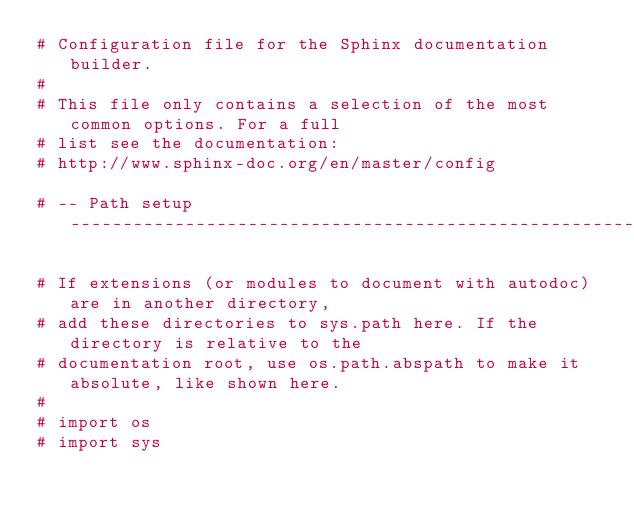<code> <loc_0><loc_0><loc_500><loc_500><_Python_># Configuration file for the Sphinx documentation builder.
#
# This file only contains a selection of the most common options. For a full
# list see the documentation:
# http://www.sphinx-doc.org/en/master/config

# -- Path setup --------------------------------------------------------------

# If extensions (or modules to document with autodoc) are in another directory,
# add these directories to sys.path here. If the directory is relative to the
# documentation root, use os.path.abspath to make it absolute, like shown here.
#
# import os
# import sys</code> 